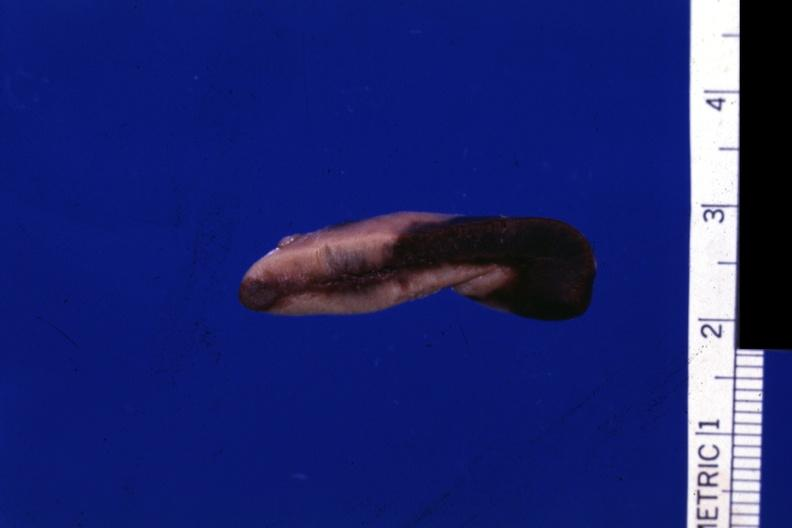what is present?
Answer the question using a single word or phrase. Endocrine 